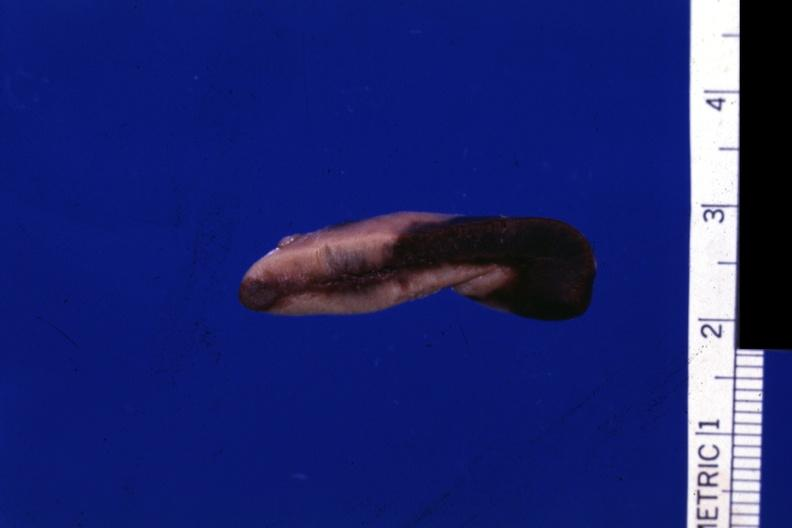what is present?
Answer the question using a single word or phrase. Endocrine 